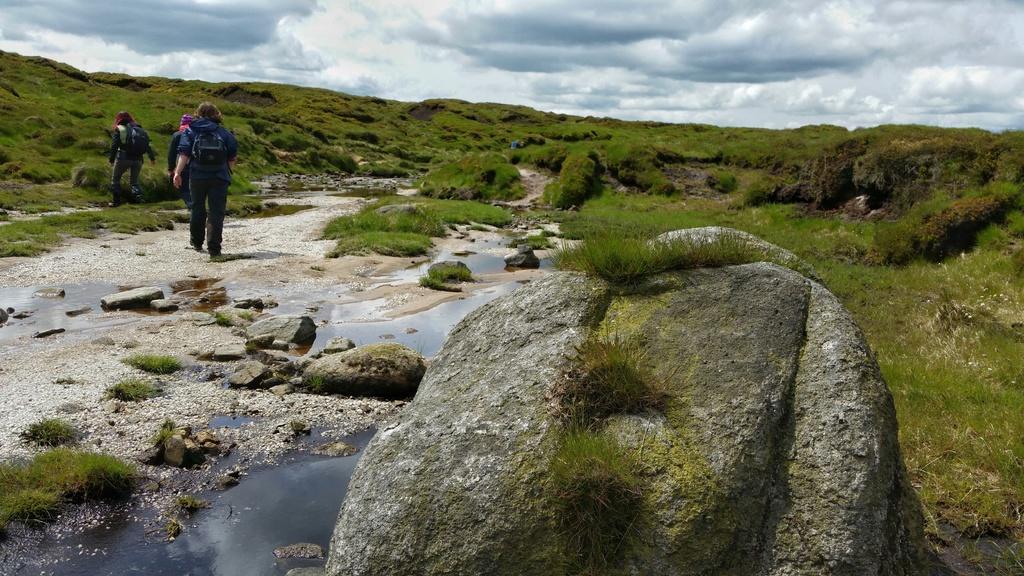Please provide a concise description of this image. In this image there are three persons walking, on the surface there is water, rocks and grass. 